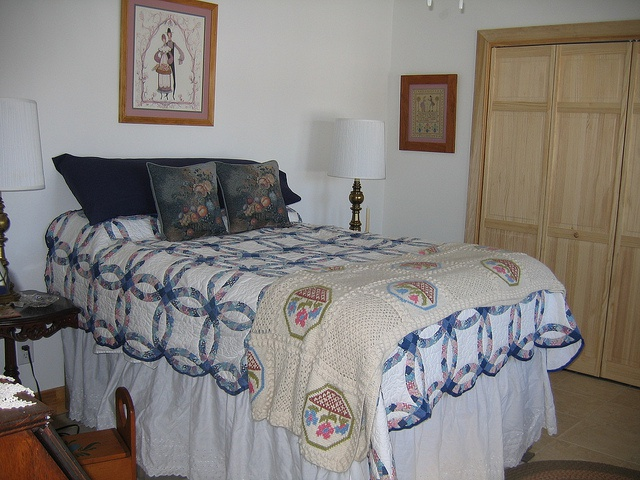Describe the objects in this image and their specific colors. I can see bed in gray, darkgray, and black tones and chair in gray, maroon, black, and purple tones in this image. 